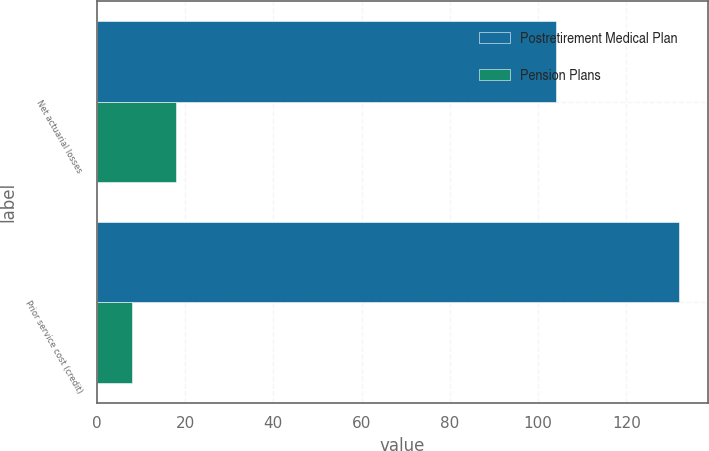Convert chart to OTSL. <chart><loc_0><loc_0><loc_500><loc_500><stacked_bar_chart><ecel><fcel>Net actuarial losses<fcel>Prior service cost (credit)<nl><fcel>Postretirement Medical Plan<fcel>104<fcel>132<nl><fcel>Pension Plans<fcel>18<fcel>8<nl></chart> 